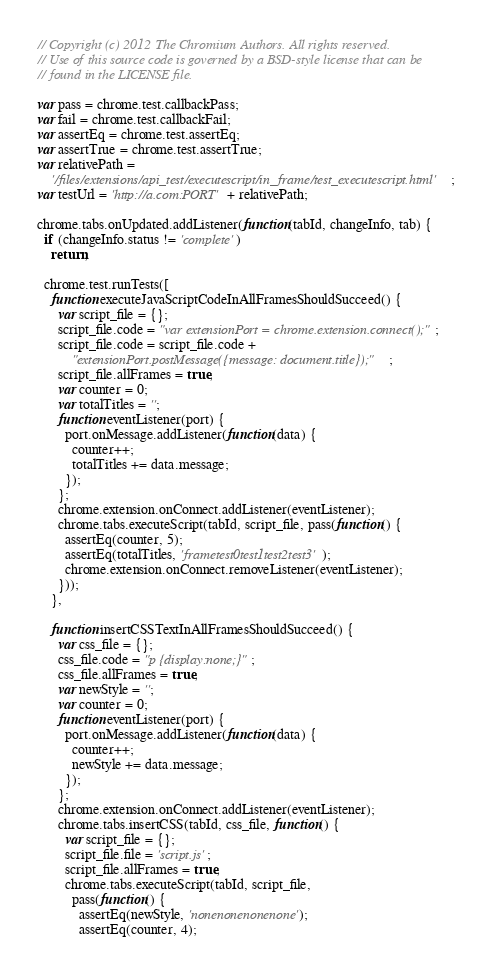<code> <loc_0><loc_0><loc_500><loc_500><_JavaScript_>// Copyright (c) 2012 The Chromium Authors. All rights reserved.
// Use of this source code is governed by a BSD-style license that can be
// found in the LICENSE file.

var pass = chrome.test.callbackPass;
var fail = chrome.test.callbackFail;
var assertEq = chrome.test.assertEq;
var assertTrue = chrome.test.assertTrue;
var relativePath =
    '/files/extensions/api_test/executescript/in_frame/test_executescript.html';
var testUrl = 'http://a.com:PORT' + relativePath;

chrome.tabs.onUpdated.addListener(function(tabId, changeInfo, tab) {
  if (changeInfo.status != 'complete')
    return;

  chrome.test.runTests([
    function executeJavaScriptCodeInAllFramesShouldSucceed() {
      var script_file = {};
      script_file.code = "var extensionPort = chrome.extension.connect();";
      script_file.code = script_file.code +
          "extensionPort.postMessage({message: document.title});";
      script_file.allFrames = true;
      var counter = 0;
      var totalTitles = '';
      function eventListener(port) {
        port.onMessage.addListener(function(data) {
          counter++;
          totalTitles += data.message;
        });
      };
      chrome.extension.onConnect.addListener(eventListener);
      chrome.tabs.executeScript(tabId, script_file, pass(function() {
        assertEq(counter, 5);
        assertEq(totalTitles, 'frametest0test1test2test3');
        chrome.extension.onConnect.removeListener(eventListener);
      }));
    },

    function insertCSSTextInAllFramesShouldSucceed() {
      var css_file = {};
      css_file.code = "p {display:none;}";
      css_file.allFrames = true;
      var newStyle = '';
      var counter = 0;
      function eventListener(port) {
        port.onMessage.addListener(function(data) {
          counter++;
          newStyle += data.message;
        });
      };
      chrome.extension.onConnect.addListener(eventListener);
      chrome.tabs.insertCSS(tabId, css_file, function() {
        var script_file = {};
        script_file.file = 'script.js';
        script_file.allFrames = true;
        chrome.tabs.executeScript(tabId, script_file,
          pass(function() {
            assertEq(newStyle, 'nonenonenonenone');
            assertEq(counter, 4);</code> 